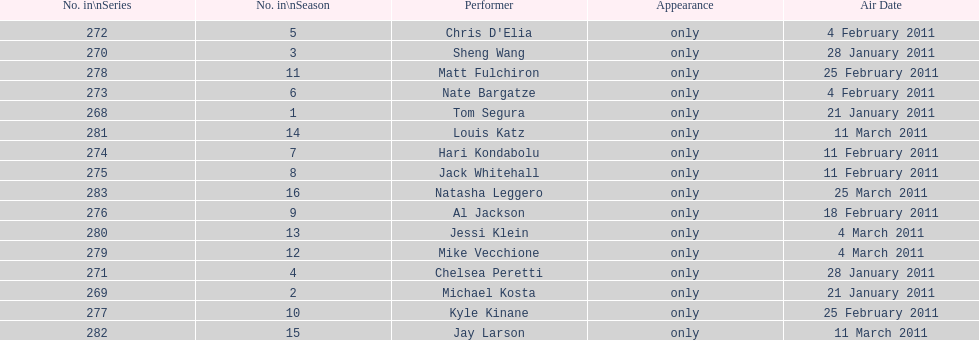What was hari's last name? Kondabolu. Could you parse the entire table? {'header': ['No. in\\nSeries', 'No. in\\nSeason', 'Performer', 'Appearance', 'Air Date'], 'rows': [['272', '5', "Chris D'Elia", 'only', '4 February 2011'], ['270', '3', 'Sheng Wang', 'only', '28 January 2011'], ['278', '11', 'Matt Fulchiron', 'only', '25 February 2011'], ['273', '6', 'Nate Bargatze', 'only', '4 February 2011'], ['268', '1', 'Tom Segura', 'only', '21 January 2011'], ['281', '14', 'Louis Katz', 'only', '11 March 2011'], ['274', '7', 'Hari Kondabolu', 'only', '11 February 2011'], ['275', '8', 'Jack Whitehall', 'only', '11 February 2011'], ['283', '16', 'Natasha Leggero', 'only', '25 March 2011'], ['276', '9', 'Al Jackson', 'only', '18 February 2011'], ['280', '13', 'Jessi Klein', 'only', '4 March 2011'], ['279', '12', 'Mike Vecchione', 'only', '4 March 2011'], ['271', '4', 'Chelsea Peretti', 'only', '28 January 2011'], ['269', '2', 'Michael Kosta', 'only', '21 January 2011'], ['277', '10', 'Kyle Kinane', 'only', '25 February 2011'], ['282', '15', 'Jay Larson', 'only', '11 March 2011']]} 